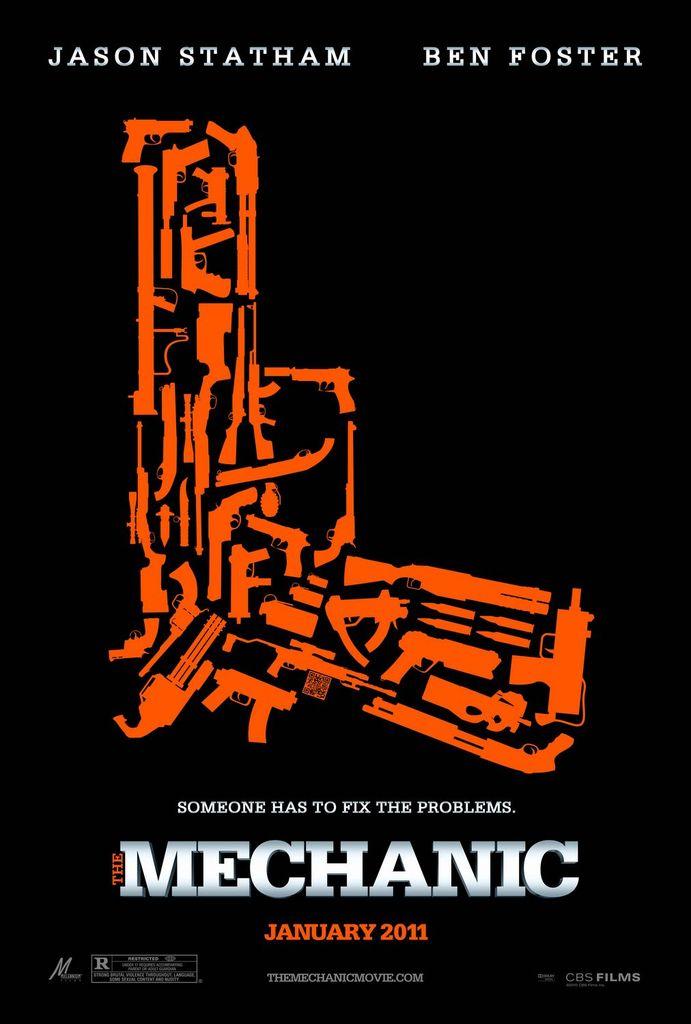What is this movie ad for?
Offer a terse response. Mechanic. Who stars in this movie?
Provide a succinct answer. Jason statham and ben foster. 